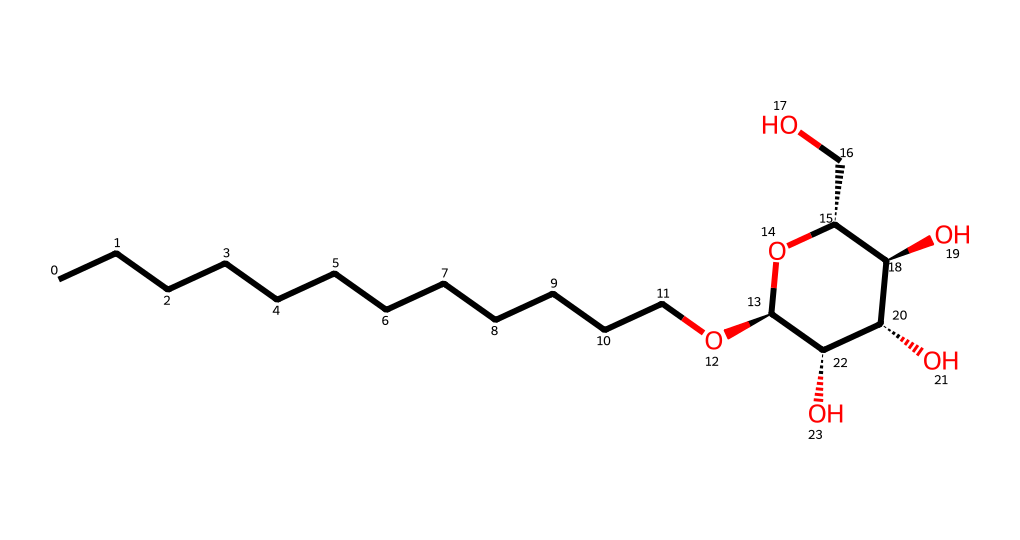What is the total number of carbon atoms in this chemical? By examining the SMILES representation, we can count the number of 'C' symbols. There are 12 'C' symbols which indicates there are 12 carbon atoms.
Answer: 12 How many hydroxyl (–OH) groups are present in this molecule? The molecule has hydroxyl groups represented by 'O' in the structure connected to carbon atoms. In total, there are 5 'O' connected to carbon chains that indicate the presence of 5 hydroxyl groups.
Answer: 5 What type of surfactant is this compound categorized as? The chemical is classified as a non-ionic surfactant due to the absence of ionic groups and the presence of a hydrophilic sugar moiety along with a hydrophobic alkyl chain.
Answer: non-ionic What is the molecular weight of this alkyl polyglucoside? By calculating based on the molecular formula derived from the SMILES, which is C12H24O5, the molecular weight is approximately 236.32 g/mol.
Answer: 236.32 g/mol What feature of this surfactant makes it eco-friendly? Alkyl polyglucosides are derived from renewable resources like glucose and fatty alcohols, which contribute to their biodegradability and eco-friendliness compared to synthetic surfactants.
Answer: biodegradability How does the alkyl chain length affect the cleaning efficacy of this surfactant? The length of the alkyl chain plays a critical role; longer chains typically enhance the surfactant's detergent capability and emulsification properties, making them more effective at removing oils and dirt.
Answer: enhances efficacy What is the primary application of alkyl polyglucosides in cleaning products? They are primarily used as emulsifiers and foam boosters in cleaning products, which help improve the effectiveness of formulations while being gentle on surfaces and the environment.
Answer: emulsifiers 